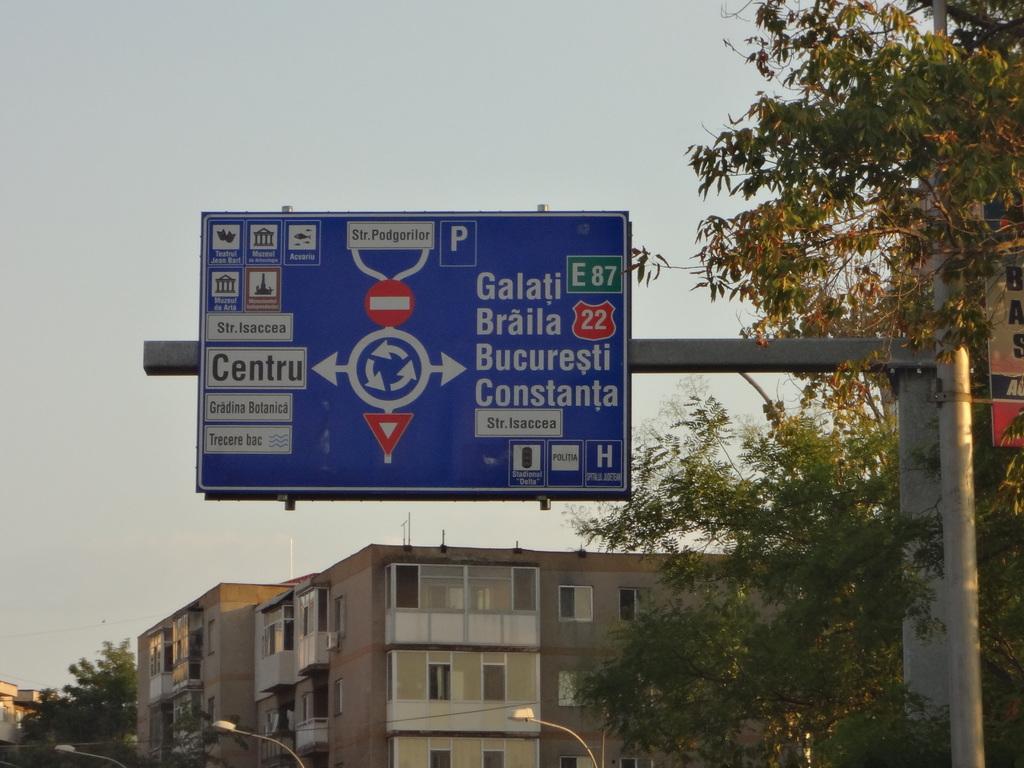Galati braila bucuresti constanta in way i can get?
Keep it short and to the point. Right. 